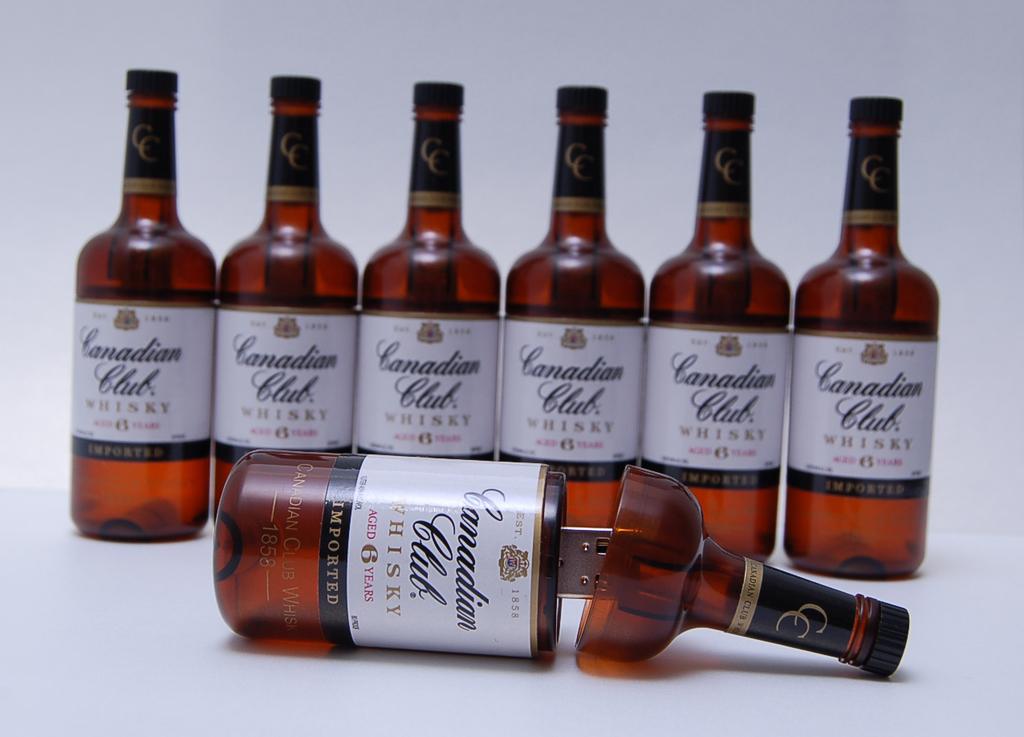How long is this whiskey aged?
Make the answer very short. 6 years. 